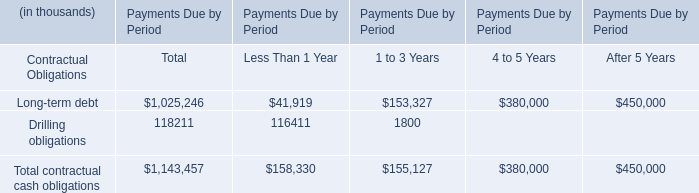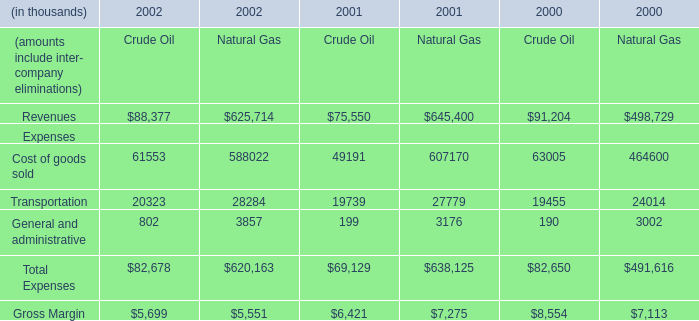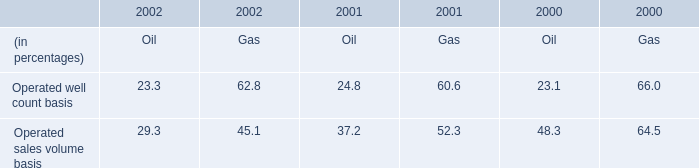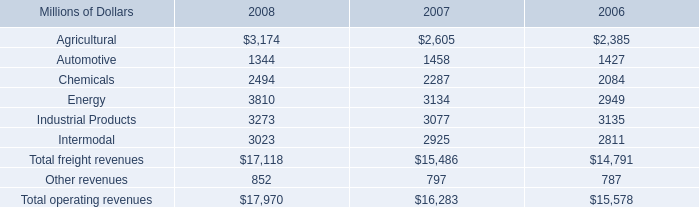Which year is the amounts include inter- company eliminations in terms of Revenues for Natural Gas the highest? 
Answer: 2001. 